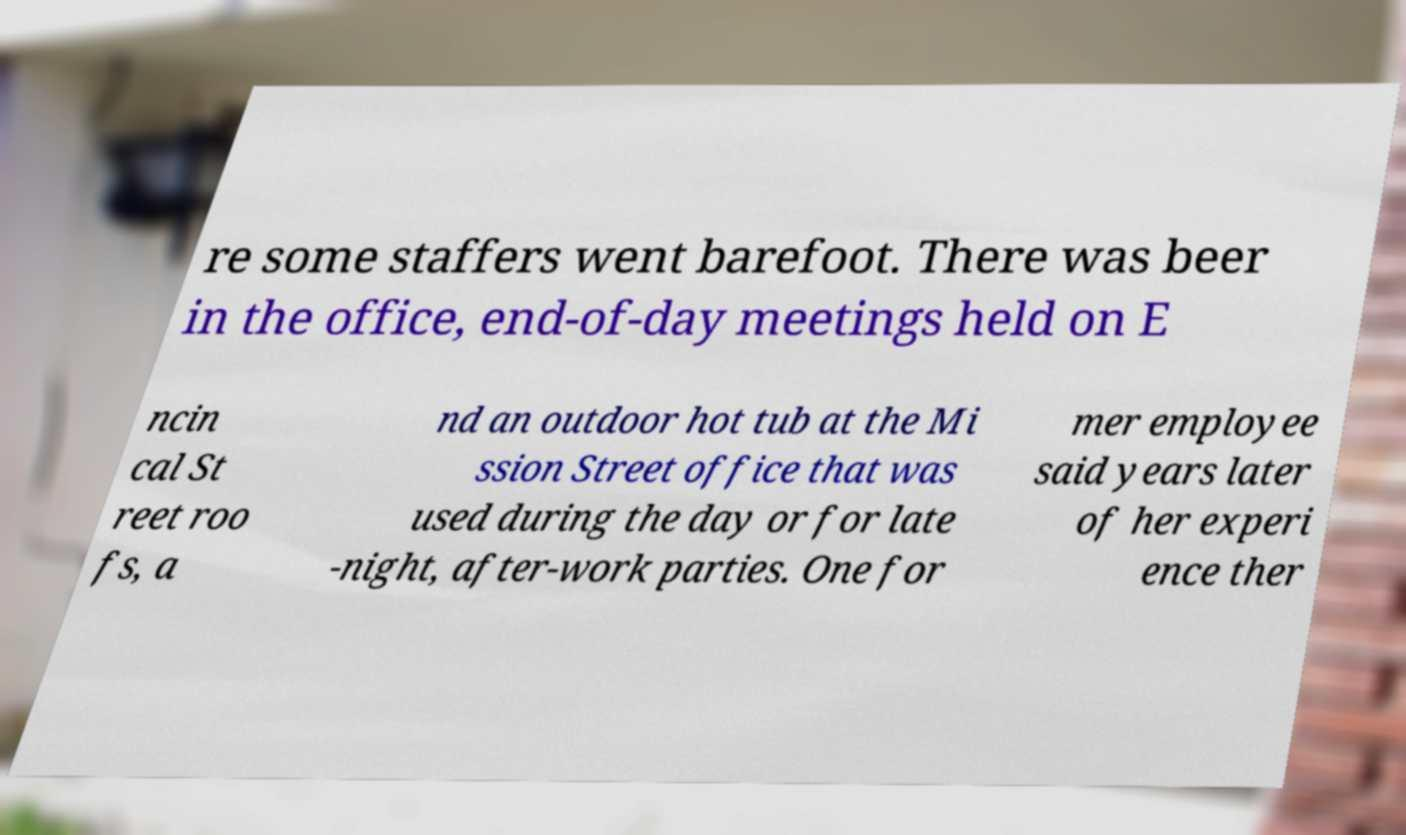Please identify and transcribe the text found in this image. re some staffers went barefoot. There was beer in the office, end-of-day meetings held on E ncin cal St reet roo fs, a nd an outdoor hot tub at the Mi ssion Street office that was used during the day or for late -night, after-work parties. One for mer employee said years later of her experi ence ther 